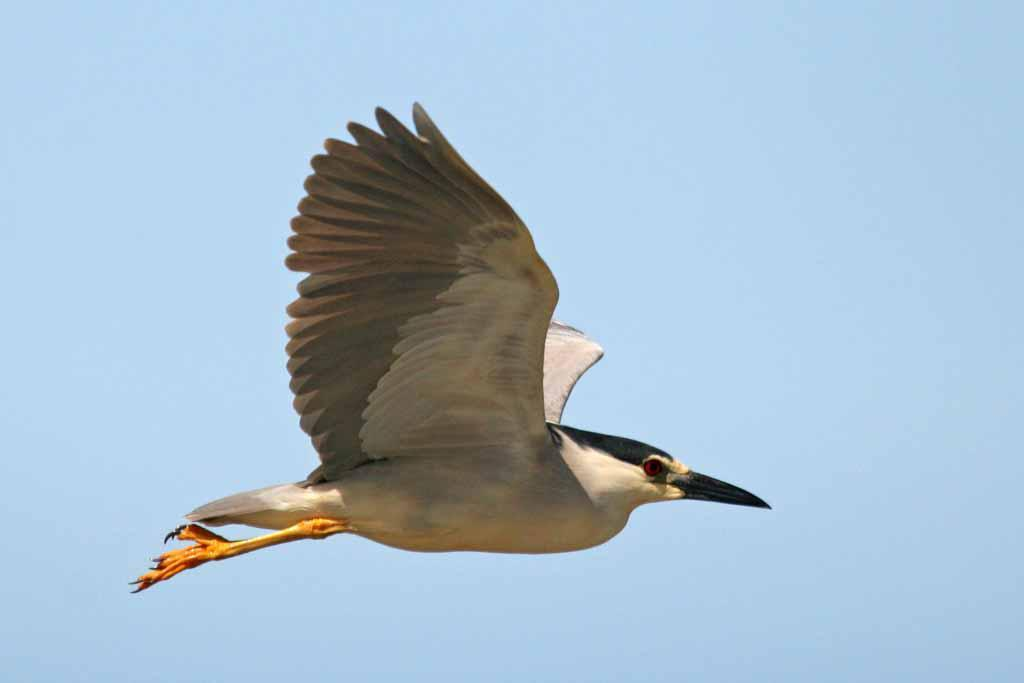What type of animal can be seen in the image? There is a bird in the image. What is the bird doing in the image? The bird is flying. What can be seen in the background of the image? The sky is visible in the background of the image. What type of wool can be seen on the bird's jeans in the image? There is no wool or jeans present in the image; it features a bird flying in the sky. 